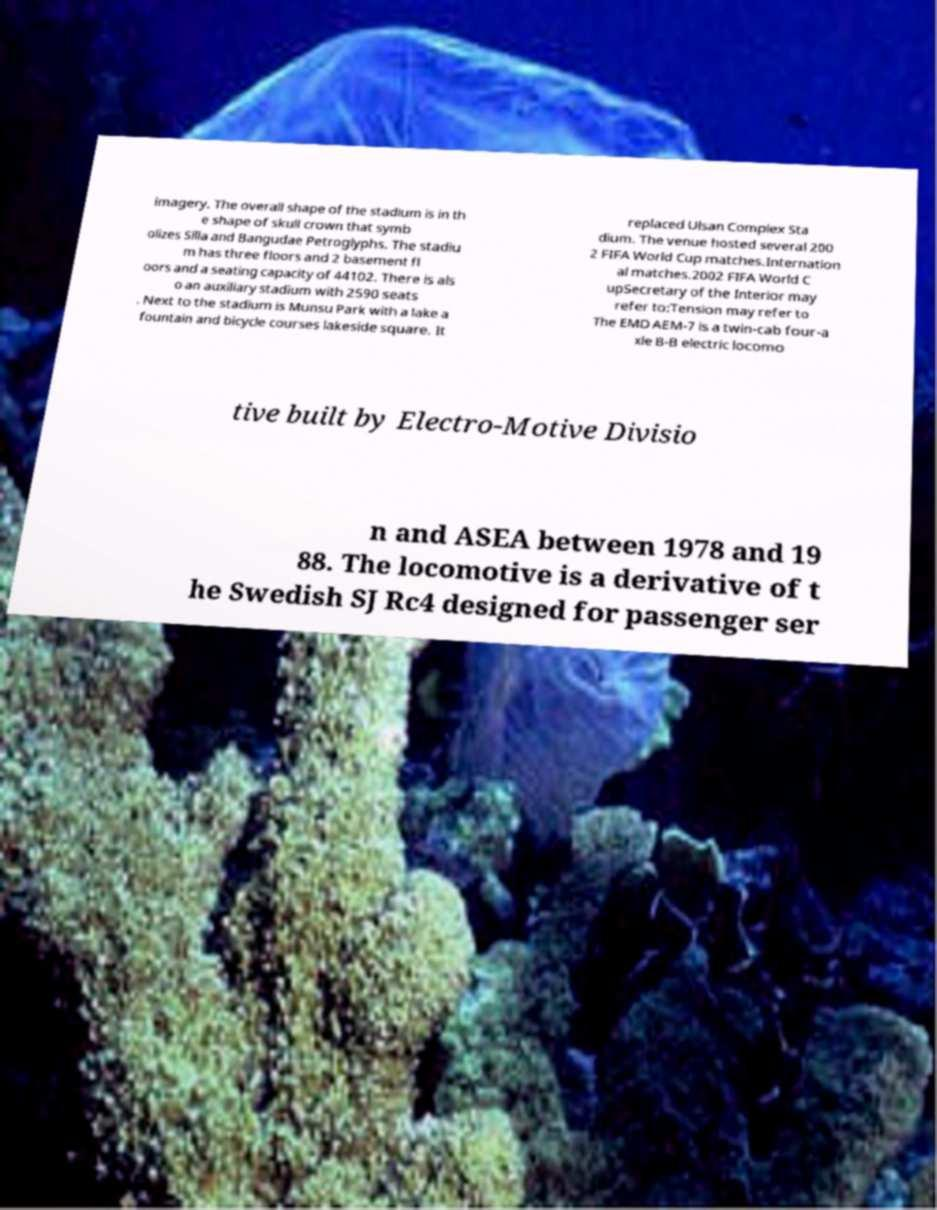For documentation purposes, I need the text within this image transcribed. Could you provide that? imagery. The overall shape of the stadium is in th e shape of skull crown that symb olizes Silla and Bangudae Petroglyphs. The stadiu m has three floors and 2 basement fl oors and a seating capacity of 44102. There is als o an auxiliary stadium with 2590 seats . Next to the stadium is Munsu Park with a lake a fountain and bicycle courses lakeside square. It replaced Ulsan Complex Sta dium. The venue hosted several 200 2 FIFA World Cup matches.Internation al matches.2002 FIFA World C upSecretary of the Interior may refer to:Tension may refer to The EMD AEM-7 is a twin-cab four-a xle B-B electric locomo tive built by Electro-Motive Divisio n and ASEA between 1978 and 19 88. The locomotive is a derivative of t he Swedish SJ Rc4 designed for passenger ser 